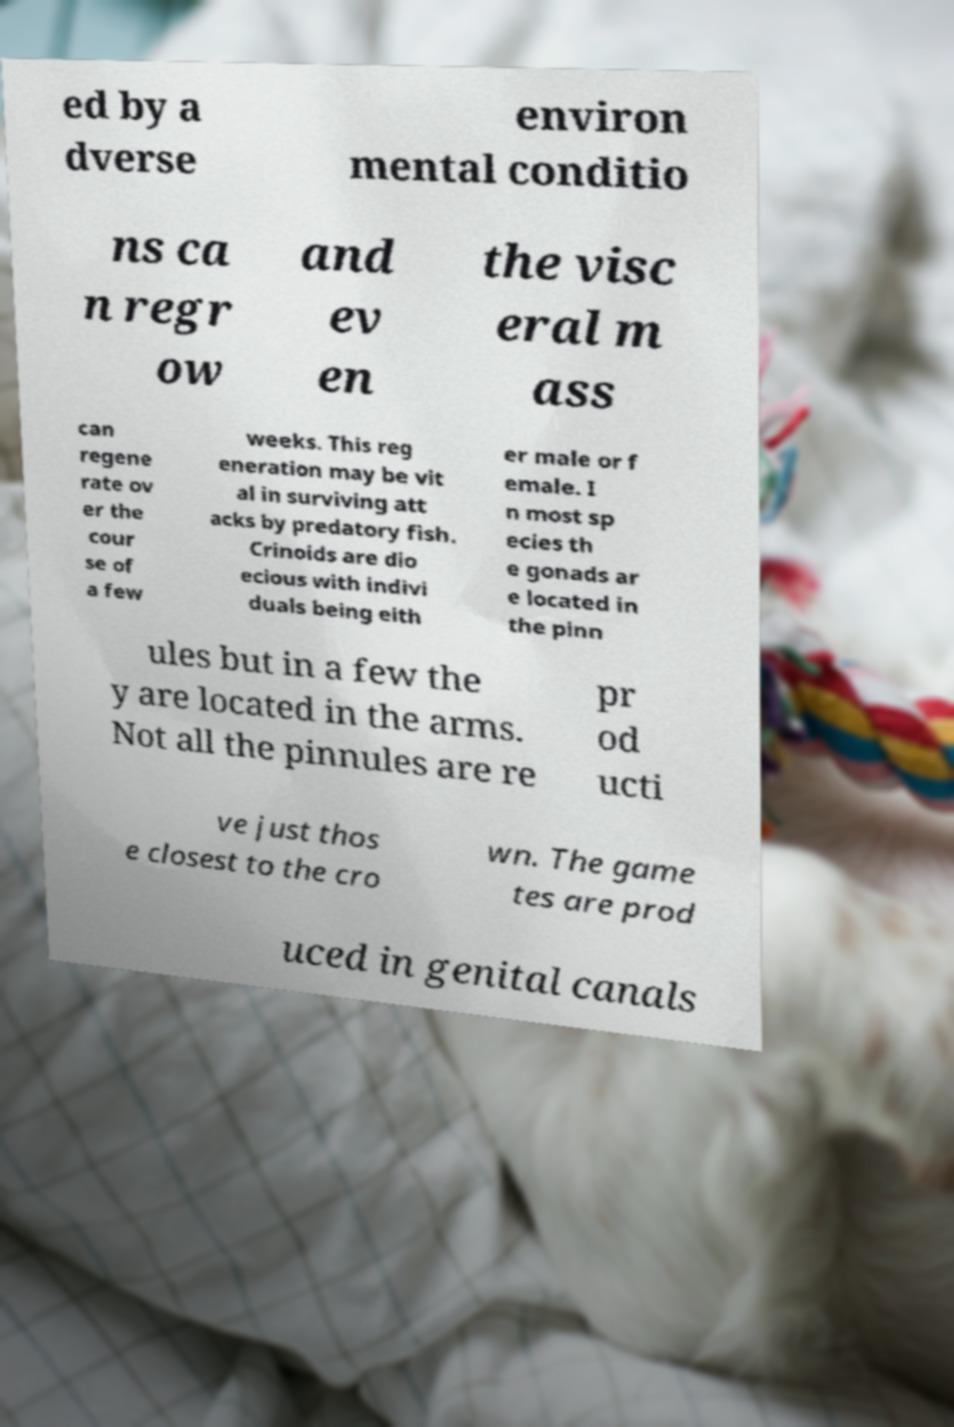For documentation purposes, I need the text within this image transcribed. Could you provide that? ed by a dverse environ mental conditio ns ca n regr ow and ev en the visc eral m ass can regene rate ov er the cour se of a few weeks. This reg eneration may be vit al in surviving att acks by predatory fish. Crinoids are dio ecious with indivi duals being eith er male or f emale. I n most sp ecies th e gonads ar e located in the pinn ules but in a few the y are located in the arms. Not all the pinnules are re pr od ucti ve just thos e closest to the cro wn. The game tes are prod uced in genital canals 